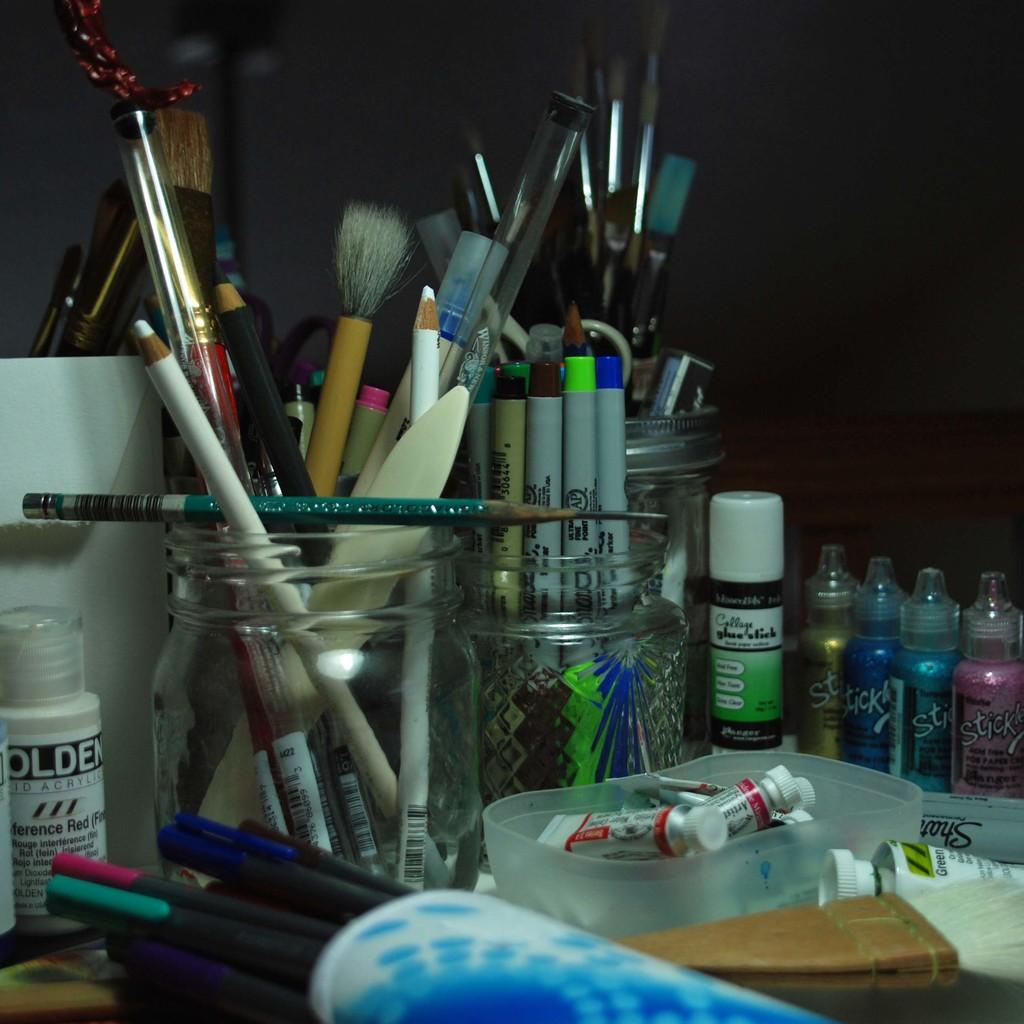What type of pain is the pink paint on the right?
Your answer should be very brief. Sticky. Is there a glue stick among the art supplies?
Your answer should be very brief. Yes. 